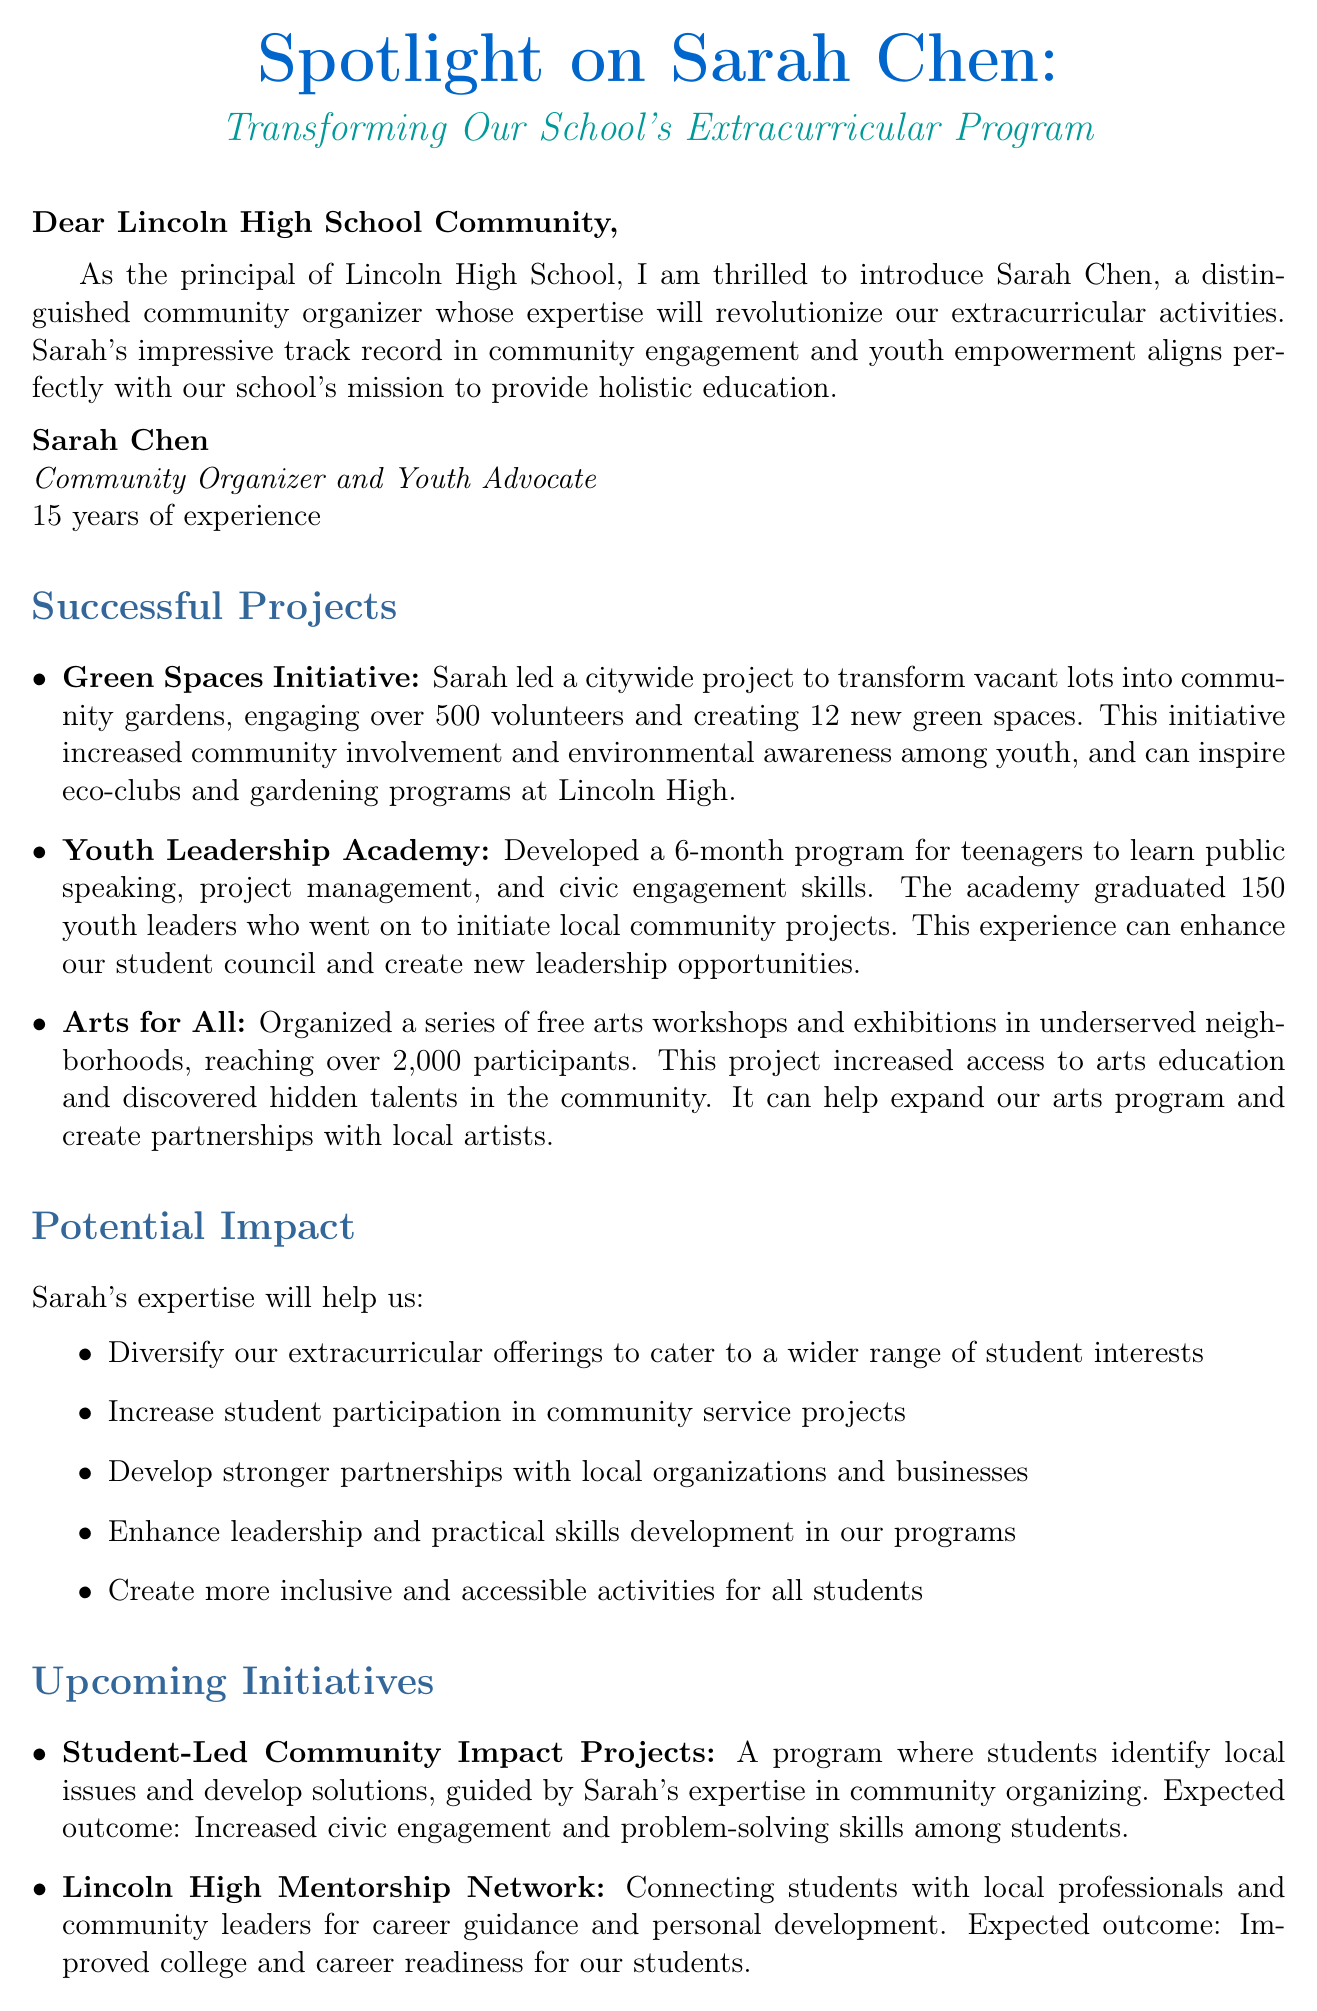What is the name of the community organizer featured in the newsletter? The document introduces Sarah Chen as the community organizer.
Answer: Sarah Chen How many years of experience does Sarah Chen have? The document states that Sarah Chen has 15 years of experience.
Answer: 15 years What initiative did Sarah lead to engage over 500 volunteers? The newsletter mentions the Green Spaces Initiative as the project led by Sarah.
Answer: Green Spaces Initiative How many youth leaders graduated from the Youth Leadership Academy? The document states that 150 youth leaders graduated from the program.
Answer: 150 What is one expected outcome of the Lincoln High Mentorship Network? The document mentions improved college and career readiness as an expected outcome.
Answer: Improved college and career readiness Which program aims to include adaptive sports for students? The Inclusive Sports and Wellness Program is designed to expand athletic offerings to include adaptive sports.
Answer: Inclusive Sports and Wellness Program What is the primary focus of the upcoming Student-Led Community Impact Projects? The focus is on students identifying local issues and developing solutions.
Answer: Identifying local issues and developing solutions What type of programs does Sarah's expertise aim to expand at Lincoln High School? The newsletter states that Sarah's expertise will help diversify extracurricular offerings.
Answer: Extracurricular offerings What role does Sarah Chen hold? The document describes Sarah Chen's role as a community organizer and youth advocate.
Answer: Community Organizer and Youth Advocate 